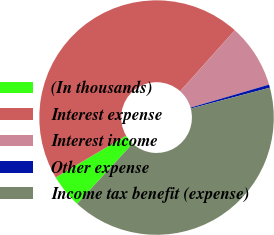<chart> <loc_0><loc_0><loc_500><loc_500><pie_chart><fcel>(In thousands)<fcel>Interest expense<fcel>Interest income<fcel>Other expense<fcel>Income tax benefit (expense)<nl><fcel>4.63%<fcel>45.15%<fcel>8.84%<fcel>0.43%<fcel>40.95%<nl></chart> 